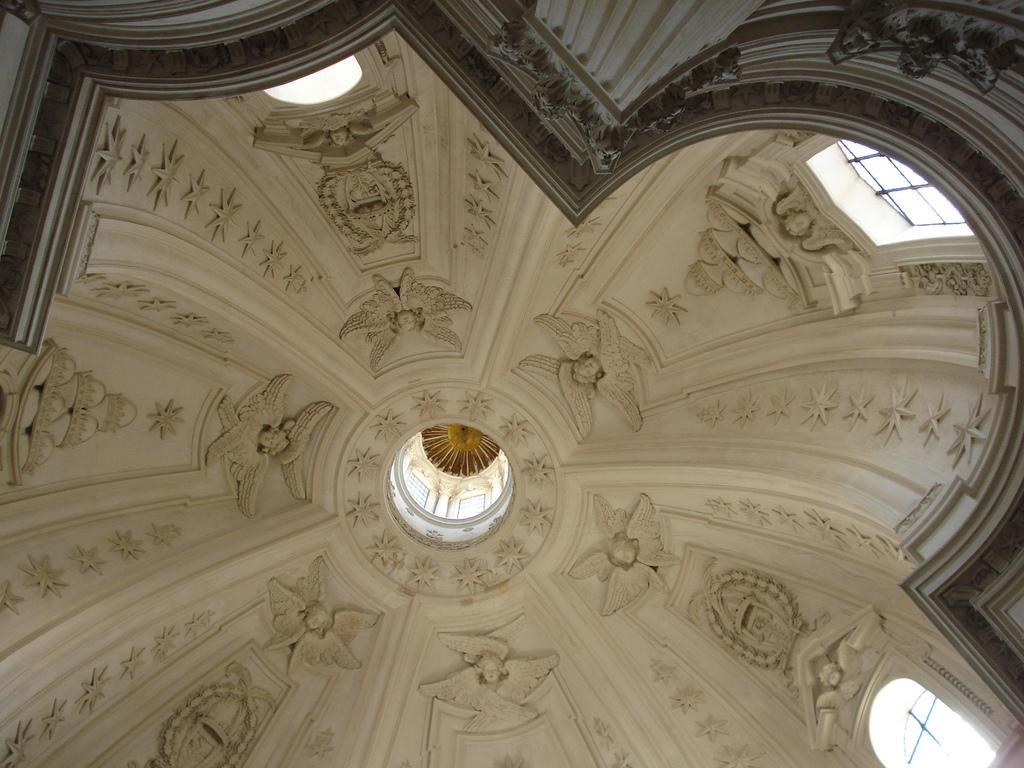In one or two sentences, can you explain what this image depicts? In this picture I can see there is a ceiling and there is sculpture on the ceiling and there is a pillar and a wall. 